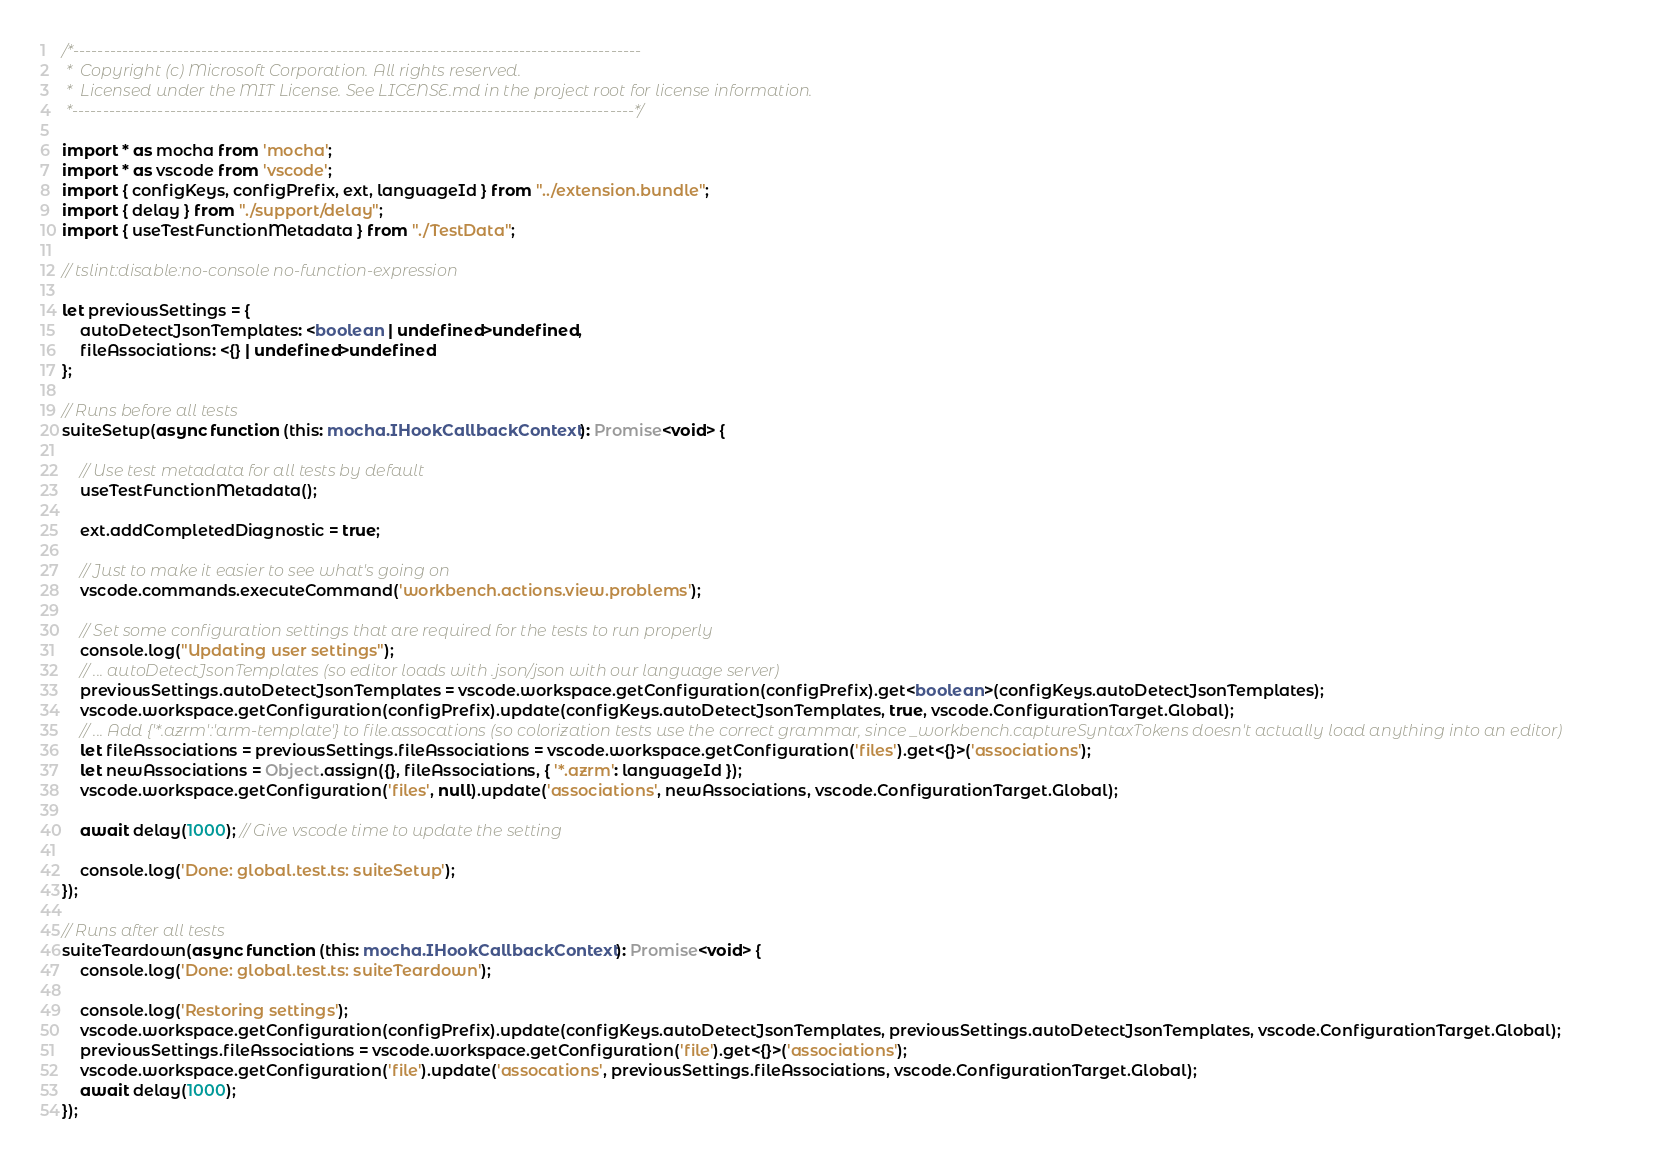Convert code to text. <code><loc_0><loc_0><loc_500><loc_500><_TypeScript_>/*---------------------------------------------------------------------------------------------
 *  Copyright (c) Microsoft Corporation. All rights reserved.
 *  Licensed under the MIT License. See LICENSE.md in the project root for license information.
 *--------------------------------------------------------------------------------------------*/

import * as mocha from 'mocha';
import * as vscode from 'vscode';
import { configKeys, configPrefix, ext, languageId } from "../extension.bundle";
import { delay } from "./support/delay";
import { useTestFunctionMetadata } from "./TestData";

// tslint:disable:no-console no-function-expression

let previousSettings = {
    autoDetectJsonTemplates: <boolean | undefined>undefined,
    fileAssociations: <{} | undefined>undefined
};

// Runs before all tests
suiteSetup(async function (this: mocha.IHookCallbackContext): Promise<void> {

    // Use test metadata for all tests by default
    useTestFunctionMetadata();

    ext.addCompletedDiagnostic = true;

    // Just to make it easier to see what's going on
    vscode.commands.executeCommand('workbench.actions.view.problems');

    // Set some configuration settings that are required for the tests to run properly
    console.log("Updating user settings");
    // ... autoDetectJsonTemplates (so editor loads with .json/json with our language server)
    previousSettings.autoDetectJsonTemplates = vscode.workspace.getConfiguration(configPrefix).get<boolean>(configKeys.autoDetectJsonTemplates);
    vscode.workspace.getConfiguration(configPrefix).update(configKeys.autoDetectJsonTemplates, true, vscode.ConfigurationTarget.Global);
    // ... Add {'*.azrm':'arm-template'} to file.assocations (so colorization tests use the correct grammar, since _workbench.captureSyntaxTokens doesn't actually load anything into an editor)
    let fileAssociations = previousSettings.fileAssociations = vscode.workspace.getConfiguration('files').get<{}>('associations');
    let newAssociations = Object.assign({}, fileAssociations, { '*.azrm': languageId });
    vscode.workspace.getConfiguration('files', null).update('associations', newAssociations, vscode.ConfigurationTarget.Global);

    await delay(1000); // Give vscode time to update the setting

    console.log('Done: global.test.ts: suiteSetup');
});

// Runs after all tests
suiteTeardown(async function (this: mocha.IHookCallbackContext): Promise<void> {
    console.log('Done: global.test.ts: suiteTeardown');

    console.log('Restoring settings');
    vscode.workspace.getConfiguration(configPrefix).update(configKeys.autoDetectJsonTemplates, previousSettings.autoDetectJsonTemplates, vscode.ConfigurationTarget.Global);
    previousSettings.fileAssociations = vscode.workspace.getConfiguration('file').get<{}>('associations');
    vscode.workspace.getConfiguration('file').update('assocations', previousSettings.fileAssociations, vscode.ConfigurationTarget.Global);
    await delay(1000);
});
</code> 